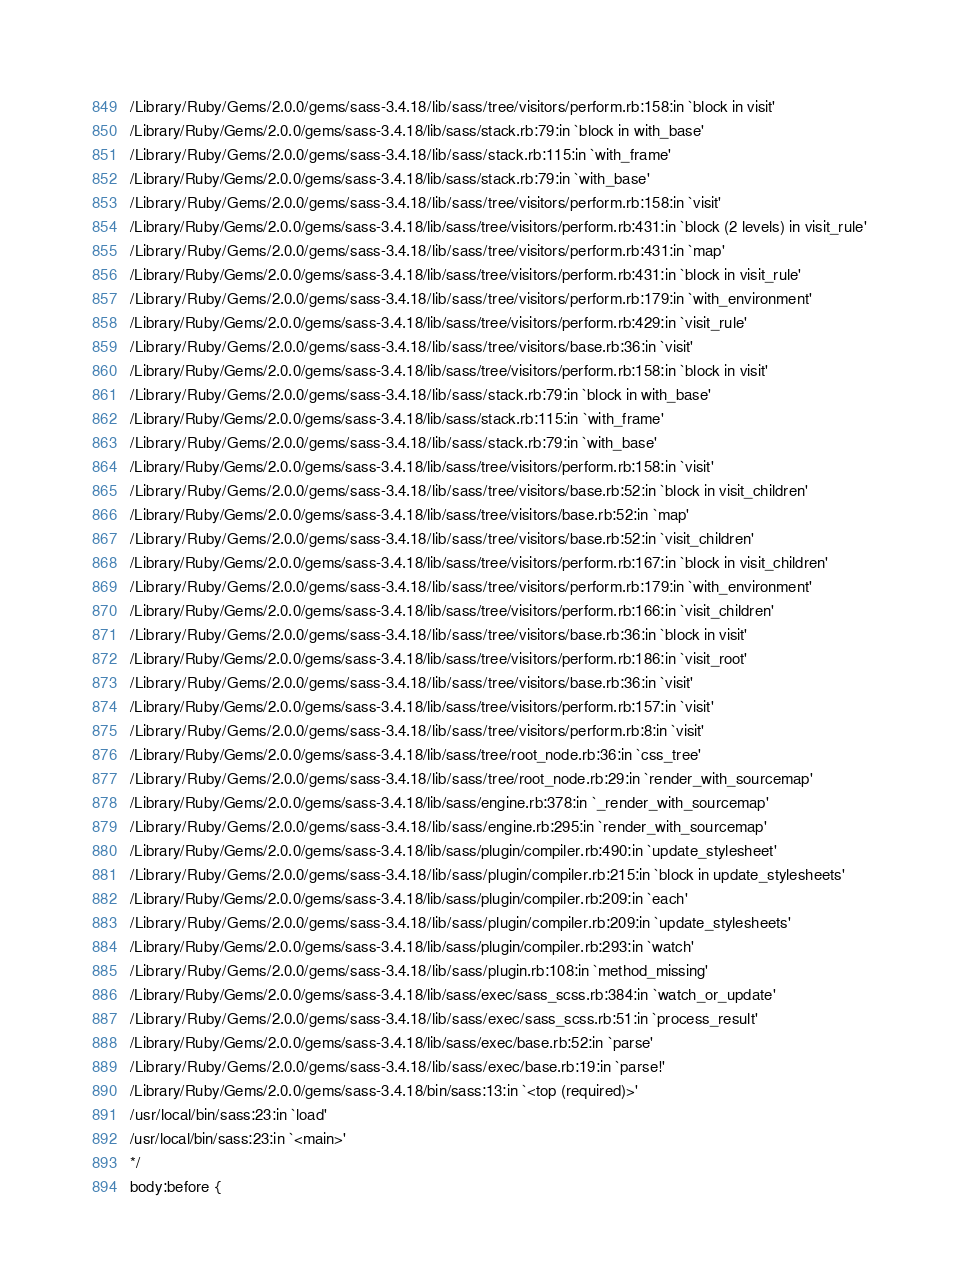<code> <loc_0><loc_0><loc_500><loc_500><_CSS_>/Library/Ruby/Gems/2.0.0/gems/sass-3.4.18/lib/sass/tree/visitors/perform.rb:158:in `block in visit'
/Library/Ruby/Gems/2.0.0/gems/sass-3.4.18/lib/sass/stack.rb:79:in `block in with_base'
/Library/Ruby/Gems/2.0.0/gems/sass-3.4.18/lib/sass/stack.rb:115:in `with_frame'
/Library/Ruby/Gems/2.0.0/gems/sass-3.4.18/lib/sass/stack.rb:79:in `with_base'
/Library/Ruby/Gems/2.0.0/gems/sass-3.4.18/lib/sass/tree/visitors/perform.rb:158:in `visit'
/Library/Ruby/Gems/2.0.0/gems/sass-3.4.18/lib/sass/tree/visitors/perform.rb:431:in `block (2 levels) in visit_rule'
/Library/Ruby/Gems/2.0.0/gems/sass-3.4.18/lib/sass/tree/visitors/perform.rb:431:in `map'
/Library/Ruby/Gems/2.0.0/gems/sass-3.4.18/lib/sass/tree/visitors/perform.rb:431:in `block in visit_rule'
/Library/Ruby/Gems/2.0.0/gems/sass-3.4.18/lib/sass/tree/visitors/perform.rb:179:in `with_environment'
/Library/Ruby/Gems/2.0.0/gems/sass-3.4.18/lib/sass/tree/visitors/perform.rb:429:in `visit_rule'
/Library/Ruby/Gems/2.0.0/gems/sass-3.4.18/lib/sass/tree/visitors/base.rb:36:in `visit'
/Library/Ruby/Gems/2.0.0/gems/sass-3.4.18/lib/sass/tree/visitors/perform.rb:158:in `block in visit'
/Library/Ruby/Gems/2.0.0/gems/sass-3.4.18/lib/sass/stack.rb:79:in `block in with_base'
/Library/Ruby/Gems/2.0.0/gems/sass-3.4.18/lib/sass/stack.rb:115:in `with_frame'
/Library/Ruby/Gems/2.0.0/gems/sass-3.4.18/lib/sass/stack.rb:79:in `with_base'
/Library/Ruby/Gems/2.0.0/gems/sass-3.4.18/lib/sass/tree/visitors/perform.rb:158:in `visit'
/Library/Ruby/Gems/2.0.0/gems/sass-3.4.18/lib/sass/tree/visitors/base.rb:52:in `block in visit_children'
/Library/Ruby/Gems/2.0.0/gems/sass-3.4.18/lib/sass/tree/visitors/base.rb:52:in `map'
/Library/Ruby/Gems/2.0.0/gems/sass-3.4.18/lib/sass/tree/visitors/base.rb:52:in `visit_children'
/Library/Ruby/Gems/2.0.0/gems/sass-3.4.18/lib/sass/tree/visitors/perform.rb:167:in `block in visit_children'
/Library/Ruby/Gems/2.0.0/gems/sass-3.4.18/lib/sass/tree/visitors/perform.rb:179:in `with_environment'
/Library/Ruby/Gems/2.0.0/gems/sass-3.4.18/lib/sass/tree/visitors/perform.rb:166:in `visit_children'
/Library/Ruby/Gems/2.0.0/gems/sass-3.4.18/lib/sass/tree/visitors/base.rb:36:in `block in visit'
/Library/Ruby/Gems/2.0.0/gems/sass-3.4.18/lib/sass/tree/visitors/perform.rb:186:in `visit_root'
/Library/Ruby/Gems/2.0.0/gems/sass-3.4.18/lib/sass/tree/visitors/base.rb:36:in `visit'
/Library/Ruby/Gems/2.0.0/gems/sass-3.4.18/lib/sass/tree/visitors/perform.rb:157:in `visit'
/Library/Ruby/Gems/2.0.0/gems/sass-3.4.18/lib/sass/tree/visitors/perform.rb:8:in `visit'
/Library/Ruby/Gems/2.0.0/gems/sass-3.4.18/lib/sass/tree/root_node.rb:36:in `css_tree'
/Library/Ruby/Gems/2.0.0/gems/sass-3.4.18/lib/sass/tree/root_node.rb:29:in `render_with_sourcemap'
/Library/Ruby/Gems/2.0.0/gems/sass-3.4.18/lib/sass/engine.rb:378:in `_render_with_sourcemap'
/Library/Ruby/Gems/2.0.0/gems/sass-3.4.18/lib/sass/engine.rb:295:in `render_with_sourcemap'
/Library/Ruby/Gems/2.0.0/gems/sass-3.4.18/lib/sass/plugin/compiler.rb:490:in `update_stylesheet'
/Library/Ruby/Gems/2.0.0/gems/sass-3.4.18/lib/sass/plugin/compiler.rb:215:in `block in update_stylesheets'
/Library/Ruby/Gems/2.0.0/gems/sass-3.4.18/lib/sass/plugin/compiler.rb:209:in `each'
/Library/Ruby/Gems/2.0.0/gems/sass-3.4.18/lib/sass/plugin/compiler.rb:209:in `update_stylesheets'
/Library/Ruby/Gems/2.0.0/gems/sass-3.4.18/lib/sass/plugin/compiler.rb:293:in `watch'
/Library/Ruby/Gems/2.0.0/gems/sass-3.4.18/lib/sass/plugin.rb:108:in `method_missing'
/Library/Ruby/Gems/2.0.0/gems/sass-3.4.18/lib/sass/exec/sass_scss.rb:384:in `watch_or_update'
/Library/Ruby/Gems/2.0.0/gems/sass-3.4.18/lib/sass/exec/sass_scss.rb:51:in `process_result'
/Library/Ruby/Gems/2.0.0/gems/sass-3.4.18/lib/sass/exec/base.rb:52:in `parse'
/Library/Ruby/Gems/2.0.0/gems/sass-3.4.18/lib/sass/exec/base.rb:19:in `parse!'
/Library/Ruby/Gems/2.0.0/gems/sass-3.4.18/bin/sass:13:in `<top (required)>'
/usr/local/bin/sass:23:in `load'
/usr/local/bin/sass:23:in `<main>'
*/
body:before {</code> 